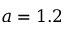<formula> <loc_0><loc_0><loc_500><loc_500>a = 1 . 2</formula> 